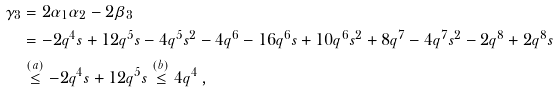<formula> <loc_0><loc_0><loc_500><loc_500>\gamma _ { 3 } & = 2 \alpha _ { 1 } \alpha _ { 2 } - 2 \beta _ { 3 } \\ & = - 2 q ^ { 4 } s + 1 2 q ^ { 5 } s - 4 q ^ { 5 } s ^ { 2 } - 4 q ^ { 6 } - 1 6 q ^ { 6 } s + 1 0 q ^ { 6 } s ^ { 2 } + 8 q ^ { 7 } - 4 q ^ { 7 } s ^ { 2 } - 2 q ^ { 8 } + 2 q ^ { 8 } s \\ & \overset { ( a ) } { \leq } - 2 q ^ { 4 } s + 1 2 q ^ { 5 } s \overset { ( b ) } { \leq } 4 q ^ { 4 } \, ,</formula> 